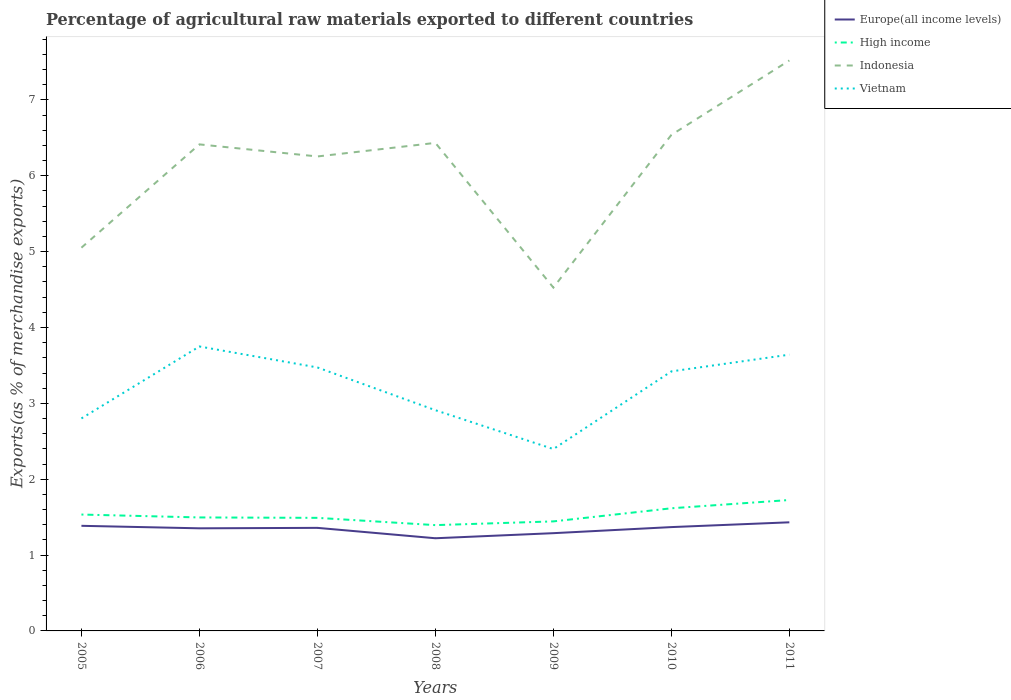How many different coloured lines are there?
Offer a terse response. 4. Does the line corresponding to High income intersect with the line corresponding to Indonesia?
Make the answer very short. No. Across all years, what is the maximum percentage of exports to different countries in Europe(all income levels)?
Your answer should be very brief. 1.22. In which year was the percentage of exports to different countries in Indonesia maximum?
Offer a terse response. 2009. What is the total percentage of exports to different countries in Indonesia in the graph?
Your answer should be very brief. 0.53. What is the difference between the highest and the second highest percentage of exports to different countries in Vietnam?
Your answer should be compact. 1.35. How many lines are there?
Provide a succinct answer. 4. How many years are there in the graph?
Provide a succinct answer. 7. What is the difference between two consecutive major ticks on the Y-axis?
Offer a terse response. 1. Are the values on the major ticks of Y-axis written in scientific E-notation?
Your answer should be compact. No. How are the legend labels stacked?
Provide a succinct answer. Vertical. What is the title of the graph?
Provide a short and direct response. Percentage of agricultural raw materials exported to different countries. Does "Germany" appear as one of the legend labels in the graph?
Offer a very short reply. No. What is the label or title of the Y-axis?
Your response must be concise. Exports(as % of merchandise exports). What is the Exports(as % of merchandise exports) in Europe(all income levels) in 2005?
Ensure brevity in your answer.  1.39. What is the Exports(as % of merchandise exports) of High income in 2005?
Your answer should be compact. 1.53. What is the Exports(as % of merchandise exports) of Indonesia in 2005?
Provide a succinct answer. 5.05. What is the Exports(as % of merchandise exports) in Vietnam in 2005?
Offer a very short reply. 2.8. What is the Exports(as % of merchandise exports) of Europe(all income levels) in 2006?
Your answer should be compact. 1.35. What is the Exports(as % of merchandise exports) of High income in 2006?
Give a very brief answer. 1.5. What is the Exports(as % of merchandise exports) in Indonesia in 2006?
Provide a succinct answer. 6.41. What is the Exports(as % of merchandise exports) in Vietnam in 2006?
Provide a succinct answer. 3.75. What is the Exports(as % of merchandise exports) in Europe(all income levels) in 2007?
Make the answer very short. 1.36. What is the Exports(as % of merchandise exports) in High income in 2007?
Offer a terse response. 1.49. What is the Exports(as % of merchandise exports) of Indonesia in 2007?
Ensure brevity in your answer.  6.25. What is the Exports(as % of merchandise exports) of Vietnam in 2007?
Your answer should be very brief. 3.47. What is the Exports(as % of merchandise exports) in Europe(all income levels) in 2008?
Offer a very short reply. 1.22. What is the Exports(as % of merchandise exports) in High income in 2008?
Offer a terse response. 1.39. What is the Exports(as % of merchandise exports) in Indonesia in 2008?
Your response must be concise. 6.43. What is the Exports(as % of merchandise exports) in Vietnam in 2008?
Offer a very short reply. 2.91. What is the Exports(as % of merchandise exports) in Europe(all income levels) in 2009?
Provide a short and direct response. 1.29. What is the Exports(as % of merchandise exports) of High income in 2009?
Ensure brevity in your answer.  1.44. What is the Exports(as % of merchandise exports) of Indonesia in 2009?
Provide a succinct answer. 4.53. What is the Exports(as % of merchandise exports) in Vietnam in 2009?
Provide a short and direct response. 2.4. What is the Exports(as % of merchandise exports) of Europe(all income levels) in 2010?
Make the answer very short. 1.37. What is the Exports(as % of merchandise exports) in High income in 2010?
Your answer should be very brief. 1.62. What is the Exports(as % of merchandise exports) in Indonesia in 2010?
Give a very brief answer. 6.54. What is the Exports(as % of merchandise exports) of Vietnam in 2010?
Give a very brief answer. 3.42. What is the Exports(as % of merchandise exports) in Europe(all income levels) in 2011?
Your answer should be very brief. 1.43. What is the Exports(as % of merchandise exports) of High income in 2011?
Offer a very short reply. 1.73. What is the Exports(as % of merchandise exports) of Indonesia in 2011?
Provide a short and direct response. 7.52. What is the Exports(as % of merchandise exports) of Vietnam in 2011?
Give a very brief answer. 3.64. Across all years, what is the maximum Exports(as % of merchandise exports) in Europe(all income levels)?
Offer a terse response. 1.43. Across all years, what is the maximum Exports(as % of merchandise exports) in High income?
Ensure brevity in your answer.  1.73. Across all years, what is the maximum Exports(as % of merchandise exports) of Indonesia?
Your answer should be very brief. 7.52. Across all years, what is the maximum Exports(as % of merchandise exports) in Vietnam?
Your response must be concise. 3.75. Across all years, what is the minimum Exports(as % of merchandise exports) of Europe(all income levels)?
Ensure brevity in your answer.  1.22. Across all years, what is the minimum Exports(as % of merchandise exports) in High income?
Make the answer very short. 1.39. Across all years, what is the minimum Exports(as % of merchandise exports) in Indonesia?
Make the answer very short. 4.53. Across all years, what is the minimum Exports(as % of merchandise exports) in Vietnam?
Your response must be concise. 2.4. What is the total Exports(as % of merchandise exports) in Europe(all income levels) in the graph?
Your response must be concise. 9.41. What is the total Exports(as % of merchandise exports) of High income in the graph?
Offer a very short reply. 10.7. What is the total Exports(as % of merchandise exports) of Indonesia in the graph?
Your answer should be very brief. 42.74. What is the total Exports(as % of merchandise exports) in Vietnam in the graph?
Your answer should be compact. 22.4. What is the difference between the Exports(as % of merchandise exports) in Europe(all income levels) in 2005 and that in 2006?
Provide a short and direct response. 0.03. What is the difference between the Exports(as % of merchandise exports) of High income in 2005 and that in 2006?
Offer a terse response. 0.04. What is the difference between the Exports(as % of merchandise exports) of Indonesia in 2005 and that in 2006?
Offer a terse response. -1.36. What is the difference between the Exports(as % of merchandise exports) of Vietnam in 2005 and that in 2006?
Keep it short and to the point. -0.95. What is the difference between the Exports(as % of merchandise exports) in Europe(all income levels) in 2005 and that in 2007?
Offer a terse response. 0.03. What is the difference between the Exports(as % of merchandise exports) in High income in 2005 and that in 2007?
Offer a very short reply. 0.04. What is the difference between the Exports(as % of merchandise exports) in Indonesia in 2005 and that in 2007?
Ensure brevity in your answer.  -1.2. What is the difference between the Exports(as % of merchandise exports) of Vietnam in 2005 and that in 2007?
Offer a very short reply. -0.67. What is the difference between the Exports(as % of merchandise exports) in Europe(all income levels) in 2005 and that in 2008?
Your answer should be compact. 0.16. What is the difference between the Exports(as % of merchandise exports) in High income in 2005 and that in 2008?
Keep it short and to the point. 0.14. What is the difference between the Exports(as % of merchandise exports) of Indonesia in 2005 and that in 2008?
Give a very brief answer. -1.38. What is the difference between the Exports(as % of merchandise exports) of Vietnam in 2005 and that in 2008?
Provide a short and direct response. -0.11. What is the difference between the Exports(as % of merchandise exports) of Europe(all income levels) in 2005 and that in 2009?
Your response must be concise. 0.1. What is the difference between the Exports(as % of merchandise exports) in High income in 2005 and that in 2009?
Ensure brevity in your answer.  0.09. What is the difference between the Exports(as % of merchandise exports) of Indonesia in 2005 and that in 2009?
Make the answer very short. 0.53. What is the difference between the Exports(as % of merchandise exports) of Vietnam in 2005 and that in 2009?
Your response must be concise. 0.4. What is the difference between the Exports(as % of merchandise exports) of Europe(all income levels) in 2005 and that in 2010?
Ensure brevity in your answer.  0.02. What is the difference between the Exports(as % of merchandise exports) of High income in 2005 and that in 2010?
Offer a very short reply. -0.08. What is the difference between the Exports(as % of merchandise exports) in Indonesia in 2005 and that in 2010?
Keep it short and to the point. -1.49. What is the difference between the Exports(as % of merchandise exports) of Vietnam in 2005 and that in 2010?
Ensure brevity in your answer.  -0.62. What is the difference between the Exports(as % of merchandise exports) of Europe(all income levels) in 2005 and that in 2011?
Ensure brevity in your answer.  -0.05. What is the difference between the Exports(as % of merchandise exports) in High income in 2005 and that in 2011?
Offer a terse response. -0.19. What is the difference between the Exports(as % of merchandise exports) in Indonesia in 2005 and that in 2011?
Ensure brevity in your answer.  -2.47. What is the difference between the Exports(as % of merchandise exports) in Vietnam in 2005 and that in 2011?
Give a very brief answer. -0.84. What is the difference between the Exports(as % of merchandise exports) of Europe(all income levels) in 2006 and that in 2007?
Offer a terse response. -0.01. What is the difference between the Exports(as % of merchandise exports) of High income in 2006 and that in 2007?
Ensure brevity in your answer.  0.01. What is the difference between the Exports(as % of merchandise exports) of Indonesia in 2006 and that in 2007?
Keep it short and to the point. 0.16. What is the difference between the Exports(as % of merchandise exports) of Vietnam in 2006 and that in 2007?
Your answer should be very brief. 0.28. What is the difference between the Exports(as % of merchandise exports) in Europe(all income levels) in 2006 and that in 2008?
Your answer should be compact. 0.13. What is the difference between the Exports(as % of merchandise exports) of High income in 2006 and that in 2008?
Your response must be concise. 0.1. What is the difference between the Exports(as % of merchandise exports) of Indonesia in 2006 and that in 2008?
Make the answer very short. -0.02. What is the difference between the Exports(as % of merchandise exports) in Vietnam in 2006 and that in 2008?
Offer a terse response. 0.84. What is the difference between the Exports(as % of merchandise exports) of Europe(all income levels) in 2006 and that in 2009?
Your answer should be compact. 0.06. What is the difference between the Exports(as % of merchandise exports) of High income in 2006 and that in 2009?
Your response must be concise. 0.05. What is the difference between the Exports(as % of merchandise exports) of Indonesia in 2006 and that in 2009?
Your answer should be compact. 1.89. What is the difference between the Exports(as % of merchandise exports) of Vietnam in 2006 and that in 2009?
Offer a very short reply. 1.35. What is the difference between the Exports(as % of merchandise exports) in Europe(all income levels) in 2006 and that in 2010?
Provide a short and direct response. -0.02. What is the difference between the Exports(as % of merchandise exports) of High income in 2006 and that in 2010?
Offer a very short reply. -0.12. What is the difference between the Exports(as % of merchandise exports) of Indonesia in 2006 and that in 2010?
Offer a terse response. -0.13. What is the difference between the Exports(as % of merchandise exports) of Vietnam in 2006 and that in 2010?
Provide a short and direct response. 0.33. What is the difference between the Exports(as % of merchandise exports) of Europe(all income levels) in 2006 and that in 2011?
Provide a short and direct response. -0.08. What is the difference between the Exports(as % of merchandise exports) of High income in 2006 and that in 2011?
Your response must be concise. -0.23. What is the difference between the Exports(as % of merchandise exports) of Indonesia in 2006 and that in 2011?
Your response must be concise. -1.11. What is the difference between the Exports(as % of merchandise exports) of Vietnam in 2006 and that in 2011?
Ensure brevity in your answer.  0.11. What is the difference between the Exports(as % of merchandise exports) of Europe(all income levels) in 2007 and that in 2008?
Provide a succinct answer. 0.14. What is the difference between the Exports(as % of merchandise exports) of High income in 2007 and that in 2008?
Your answer should be compact. 0.1. What is the difference between the Exports(as % of merchandise exports) of Indonesia in 2007 and that in 2008?
Offer a very short reply. -0.18. What is the difference between the Exports(as % of merchandise exports) of Vietnam in 2007 and that in 2008?
Your answer should be very brief. 0.56. What is the difference between the Exports(as % of merchandise exports) of Europe(all income levels) in 2007 and that in 2009?
Give a very brief answer. 0.07. What is the difference between the Exports(as % of merchandise exports) in High income in 2007 and that in 2009?
Provide a succinct answer. 0.05. What is the difference between the Exports(as % of merchandise exports) in Indonesia in 2007 and that in 2009?
Offer a terse response. 1.73. What is the difference between the Exports(as % of merchandise exports) in Vietnam in 2007 and that in 2009?
Offer a very short reply. 1.08. What is the difference between the Exports(as % of merchandise exports) of Europe(all income levels) in 2007 and that in 2010?
Your response must be concise. -0.01. What is the difference between the Exports(as % of merchandise exports) of High income in 2007 and that in 2010?
Ensure brevity in your answer.  -0.13. What is the difference between the Exports(as % of merchandise exports) in Indonesia in 2007 and that in 2010?
Offer a very short reply. -0.28. What is the difference between the Exports(as % of merchandise exports) of Vietnam in 2007 and that in 2010?
Offer a very short reply. 0.05. What is the difference between the Exports(as % of merchandise exports) of Europe(all income levels) in 2007 and that in 2011?
Ensure brevity in your answer.  -0.07. What is the difference between the Exports(as % of merchandise exports) in High income in 2007 and that in 2011?
Give a very brief answer. -0.24. What is the difference between the Exports(as % of merchandise exports) of Indonesia in 2007 and that in 2011?
Your response must be concise. -1.27. What is the difference between the Exports(as % of merchandise exports) in Vietnam in 2007 and that in 2011?
Give a very brief answer. -0.17. What is the difference between the Exports(as % of merchandise exports) of Europe(all income levels) in 2008 and that in 2009?
Ensure brevity in your answer.  -0.07. What is the difference between the Exports(as % of merchandise exports) of High income in 2008 and that in 2009?
Keep it short and to the point. -0.05. What is the difference between the Exports(as % of merchandise exports) in Indonesia in 2008 and that in 2009?
Give a very brief answer. 1.91. What is the difference between the Exports(as % of merchandise exports) in Vietnam in 2008 and that in 2009?
Offer a very short reply. 0.51. What is the difference between the Exports(as % of merchandise exports) of Europe(all income levels) in 2008 and that in 2010?
Give a very brief answer. -0.15. What is the difference between the Exports(as % of merchandise exports) in High income in 2008 and that in 2010?
Give a very brief answer. -0.22. What is the difference between the Exports(as % of merchandise exports) in Indonesia in 2008 and that in 2010?
Provide a short and direct response. -0.11. What is the difference between the Exports(as % of merchandise exports) in Vietnam in 2008 and that in 2010?
Your response must be concise. -0.51. What is the difference between the Exports(as % of merchandise exports) in Europe(all income levels) in 2008 and that in 2011?
Your response must be concise. -0.21. What is the difference between the Exports(as % of merchandise exports) in High income in 2008 and that in 2011?
Give a very brief answer. -0.33. What is the difference between the Exports(as % of merchandise exports) of Indonesia in 2008 and that in 2011?
Provide a succinct answer. -1.09. What is the difference between the Exports(as % of merchandise exports) of Vietnam in 2008 and that in 2011?
Offer a terse response. -0.73. What is the difference between the Exports(as % of merchandise exports) in Europe(all income levels) in 2009 and that in 2010?
Ensure brevity in your answer.  -0.08. What is the difference between the Exports(as % of merchandise exports) in High income in 2009 and that in 2010?
Keep it short and to the point. -0.17. What is the difference between the Exports(as % of merchandise exports) of Indonesia in 2009 and that in 2010?
Offer a very short reply. -2.01. What is the difference between the Exports(as % of merchandise exports) of Vietnam in 2009 and that in 2010?
Your response must be concise. -1.02. What is the difference between the Exports(as % of merchandise exports) in Europe(all income levels) in 2009 and that in 2011?
Ensure brevity in your answer.  -0.14. What is the difference between the Exports(as % of merchandise exports) in High income in 2009 and that in 2011?
Your answer should be very brief. -0.28. What is the difference between the Exports(as % of merchandise exports) in Indonesia in 2009 and that in 2011?
Your answer should be very brief. -2.99. What is the difference between the Exports(as % of merchandise exports) in Vietnam in 2009 and that in 2011?
Your answer should be compact. -1.24. What is the difference between the Exports(as % of merchandise exports) in Europe(all income levels) in 2010 and that in 2011?
Keep it short and to the point. -0.06. What is the difference between the Exports(as % of merchandise exports) of High income in 2010 and that in 2011?
Your answer should be very brief. -0.11. What is the difference between the Exports(as % of merchandise exports) of Indonesia in 2010 and that in 2011?
Provide a succinct answer. -0.98. What is the difference between the Exports(as % of merchandise exports) in Vietnam in 2010 and that in 2011?
Keep it short and to the point. -0.22. What is the difference between the Exports(as % of merchandise exports) of Europe(all income levels) in 2005 and the Exports(as % of merchandise exports) of High income in 2006?
Your answer should be very brief. -0.11. What is the difference between the Exports(as % of merchandise exports) in Europe(all income levels) in 2005 and the Exports(as % of merchandise exports) in Indonesia in 2006?
Give a very brief answer. -5.03. What is the difference between the Exports(as % of merchandise exports) of Europe(all income levels) in 2005 and the Exports(as % of merchandise exports) of Vietnam in 2006?
Your answer should be very brief. -2.36. What is the difference between the Exports(as % of merchandise exports) in High income in 2005 and the Exports(as % of merchandise exports) in Indonesia in 2006?
Your answer should be compact. -4.88. What is the difference between the Exports(as % of merchandise exports) of High income in 2005 and the Exports(as % of merchandise exports) of Vietnam in 2006?
Your response must be concise. -2.22. What is the difference between the Exports(as % of merchandise exports) in Indonesia in 2005 and the Exports(as % of merchandise exports) in Vietnam in 2006?
Ensure brevity in your answer.  1.3. What is the difference between the Exports(as % of merchandise exports) of Europe(all income levels) in 2005 and the Exports(as % of merchandise exports) of High income in 2007?
Offer a terse response. -0.1. What is the difference between the Exports(as % of merchandise exports) of Europe(all income levels) in 2005 and the Exports(as % of merchandise exports) of Indonesia in 2007?
Ensure brevity in your answer.  -4.87. What is the difference between the Exports(as % of merchandise exports) of Europe(all income levels) in 2005 and the Exports(as % of merchandise exports) of Vietnam in 2007?
Provide a succinct answer. -2.09. What is the difference between the Exports(as % of merchandise exports) in High income in 2005 and the Exports(as % of merchandise exports) in Indonesia in 2007?
Provide a short and direct response. -4.72. What is the difference between the Exports(as % of merchandise exports) in High income in 2005 and the Exports(as % of merchandise exports) in Vietnam in 2007?
Make the answer very short. -1.94. What is the difference between the Exports(as % of merchandise exports) in Indonesia in 2005 and the Exports(as % of merchandise exports) in Vietnam in 2007?
Keep it short and to the point. 1.58. What is the difference between the Exports(as % of merchandise exports) in Europe(all income levels) in 2005 and the Exports(as % of merchandise exports) in High income in 2008?
Your answer should be very brief. -0.01. What is the difference between the Exports(as % of merchandise exports) in Europe(all income levels) in 2005 and the Exports(as % of merchandise exports) in Indonesia in 2008?
Give a very brief answer. -5.05. What is the difference between the Exports(as % of merchandise exports) of Europe(all income levels) in 2005 and the Exports(as % of merchandise exports) of Vietnam in 2008?
Provide a succinct answer. -1.52. What is the difference between the Exports(as % of merchandise exports) in High income in 2005 and the Exports(as % of merchandise exports) in Indonesia in 2008?
Offer a very short reply. -4.9. What is the difference between the Exports(as % of merchandise exports) in High income in 2005 and the Exports(as % of merchandise exports) in Vietnam in 2008?
Provide a succinct answer. -1.38. What is the difference between the Exports(as % of merchandise exports) in Indonesia in 2005 and the Exports(as % of merchandise exports) in Vietnam in 2008?
Offer a terse response. 2.14. What is the difference between the Exports(as % of merchandise exports) of Europe(all income levels) in 2005 and the Exports(as % of merchandise exports) of High income in 2009?
Provide a succinct answer. -0.06. What is the difference between the Exports(as % of merchandise exports) in Europe(all income levels) in 2005 and the Exports(as % of merchandise exports) in Indonesia in 2009?
Your response must be concise. -3.14. What is the difference between the Exports(as % of merchandise exports) in Europe(all income levels) in 2005 and the Exports(as % of merchandise exports) in Vietnam in 2009?
Your answer should be very brief. -1.01. What is the difference between the Exports(as % of merchandise exports) in High income in 2005 and the Exports(as % of merchandise exports) in Indonesia in 2009?
Provide a succinct answer. -2.99. What is the difference between the Exports(as % of merchandise exports) in High income in 2005 and the Exports(as % of merchandise exports) in Vietnam in 2009?
Provide a short and direct response. -0.86. What is the difference between the Exports(as % of merchandise exports) of Indonesia in 2005 and the Exports(as % of merchandise exports) of Vietnam in 2009?
Your response must be concise. 2.65. What is the difference between the Exports(as % of merchandise exports) in Europe(all income levels) in 2005 and the Exports(as % of merchandise exports) in High income in 2010?
Give a very brief answer. -0.23. What is the difference between the Exports(as % of merchandise exports) of Europe(all income levels) in 2005 and the Exports(as % of merchandise exports) of Indonesia in 2010?
Your answer should be compact. -5.15. What is the difference between the Exports(as % of merchandise exports) in Europe(all income levels) in 2005 and the Exports(as % of merchandise exports) in Vietnam in 2010?
Provide a succinct answer. -2.04. What is the difference between the Exports(as % of merchandise exports) of High income in 2005 and the Exports(as % of merchandise exports) of Indonesia in 2010?
Your answer should be very brief. -5. What is the difference between the Exports(as % of merchandise exports) in High income in 2005 and the Exports(as % of merchandise exports) in Vietnam in 2010?
Keep it short and to the point. -1.89. What is the difference between the Exports(as % of merchandise exports) in Indonesia in 2005 and the Exports(as % of merchandise exports) in Vietnam in 2010?
Offer a very short reply. 1.63. What is the difference between the Exports(as % of merchandise exports) of Europe(all income levels) in 2005 and the Exports(as % of merchandise exports) of High income in 2011?
Offer a very short reply. -0.34. What is the difference between the Exports(as % of merchandise exports) of Europe(all income levels) in 2005 and the Exports(as % of merchandise exports) of Indonesia in 2011?
Provide a succinct answer. -6.13. What is the difference between the Exports(as % of merchandise exports) in Europe(all income levels) in 2005 and the Exports(as % of merchandise exports) in Vietnam in 2011?
Offer a very short reply. -2.26. What is the difference between the Exports(as % of merchandise exports) in High income in 2005 and the Exports(as % of merchandise exports) in Indonesia in 2011?
Provide a succinct answer. -5.99. What is the difference between the Exports(as % of merchandise exports) of High income in 2005 and the Exports(as % of merchandise exports) of Vietnam in 2011?
Your response must be concise. -2.11. What is the difference between the Exports(as % of merchandise exports) in Indonesia in 2005 and the Exports(as % of merchandise exports) in Vietnam in 2011?
Your answer should be compact. 1.41. What is the difference between the Exports(as % of merchandise exports) of Europe(all income levels) in 2006 and the Exports(as % of merchandise exports) of High income in 2007?
Your response must be concise. -0.14. What is the difference between the Exports(as % of merchandise exports) of Europe(all income levels) in 2006 and the Exports(as % of merchandise exports) of Indonesia in 2007?
Provide a succinct answer. -4.9. What is the difference between the Exports(as % of merchandise exports) in Europe(all income levels) in 2006 and the Exports(as % of merchandise exports) in Vietnam in 2007?
Make the answer very short. -2.12. What is the difference between the Exports(as % of merchandise exports) in High income in 2006 and the Exports(as % of merchandise exports) in Indonesia in 2007?
Offer a terse response. -4.76. What is the difference between the Exports(as % of merchandise exports) in High income in 2006 and the Exports(as % of merchandise exports) in Vietnam in 2007?
Provide a short and direct response. -1.98. What is the difference between the Exports(as % of merchandise exports) of Indonesia in 2006 and the Exports(as % of merchandise exports) of Vietnam in 2007?
Keep it short and to the point. 2.94. What is the difference between the Exports(as % of merchandise exports) of Europe(all income levels) in 2006 and the Exports(as % of merchandise exports) of High income in 2008?
Make the answer very short. -0.04. What is the difference between the Exports(as % of merchandise exports) in Europe(all income levels) in 2006 and the Exports(as % of merchandise exports) in Indonesia in 2008?
Give a very brief answer. -5.08. What is the difference between the Exports(as % of merchandise exports) in Europe(all income levels) in 2006 and the Exports(as % of merchandise exports) in Vietnam in 2008?
Offer a terse response. -1.56. What is the difference between the Exports(as % of merchandise exports) of High income in 2006 and the Exports(as % of merchandise exports) of Indonesia in 2008?
Offer a very short reply. -4.94. What is the difference between the Exports(as % of merchandise exports) in High income in 2006 and the Exports(as % of merchandise exports) in Vietnam in 2008?
Your answer should be compact. -1.41. What is the difference between the Exports(as % of merchandise exports) in Indonesia in 2006 and the Exports(as % of merchandise exports) in Vietnam in 2008?
Your answer should be very brief. 3.5. What is the difference between the Exports(as % of merchandise exports) in Europe(all income levels) in 2006 and the Exports(as % of merchandise exports) in High income in 2009?
Keep it short and to the point. -0.09. What is the difference between the Exports(as % of merchandise exports) of Europe(all income levels) in 2006 and the Exports(as % of merchandise exports) of Indonesia in 2009?
Make the answer very short. -3.17. What is the difference between the Exports(as % of merchandise exports) of Europe(all income levels) in 2006 and the Exports(as % of merchandise exports) of Vietnam in 2009?
Your answer should be compact. -1.04. What is the difference between the Exports(as % of merchandise exports) in High income in 2006 and the Exports(as % of merchandise exports) in Indonesia in 2009?
Make the answer very short. -3.03. What is the difference between the Exports(as % of merchandise exports) of High income in 2006 and the Exports(as % of merchandise exports) of Vietnam in 2009?
Offer a very short reply. -0.9. What is the difference between the Exports(as % of merchandise exports) of Indonesia in 2006 and the Exports(as % of merchandise exports) of Vietnam in 2009?
Provide a succinct answer. 4.02. What is the difference between the Exports(as % of merchandise exports) of Europe(all income levels) in 2006 and the Exports(as % of merchandise exports) of High income in 2010?
Your answer should be compact. -0.26. What is the difference between the Exports(as % of merchandise exports) of Europe(all income levels) in 2006 and the Exports(as % of merchandise exports) of Indonesia in 2010?
Offer a terse response. -5.19. What is the difference between the Exports(as % of merchandise exports) in Europe(all income levels) in 2006 and the Exports(as % of merchandise exports) in Vietnam in 2010?
Make the answer very short. -2.07. What is the difference between the Exports(as % of merchandise exports) of High income in 2006 and the Exports(as % of merchandise exports) of Indonesia in 2010?
Keep it short and to the point. -5.04. What is the difference between the Exports(as % of merchandise exports) of High income in 2006 and the Exports(as % of merchandise exports) of Vietnam in 2010?
Keep it short and to the point. -1.93. What is the difference between the Exports(as % of merchandise exports) of Indonesia in 2006 and the Exports(as % of merchandise exports) of Vietnam in 2010?
Your response must be concise. 2.99. What is the difference between the Exports(as % of merchandise exports) of Europe(all income levels) in 2006 and the Exports(as % of merchandise exports) of High income in 2011?
Your response must be concise. -0.37. What is the difference between the Exports(as % of merchandise exports) of Europe(all income levels) in 2006 and the Exports(as % of merchandise exports) of Indonesia in 2011?
Offer a terse response. -6.17. What is the difference between the Exports(as % of merchandise exports) in Europe(all income levels) in 2006 and the Exports(as % of merchandise exports) in Vietnam in 2011?
Offer a terse response. -2.29. What is the difference between the Exports(as % of merchandise exports) in High income in 2006 and the Exports(as % of merchandise exports) in Indonesia in 2011?
Offer a very short reply. -6.02. What is the difference between the Exports(as % of merchandise exports) of High income in 2006 and the Exports(as % of merchandise exports) of Vietnam in 2011?
Make the answer very short. -2.15. What is the difference between the Exports(as % of merchandise exports) of Indonesia in 2006 and the Exports(as % of merchandise exports) of Vietnam in 2011?
Your answer should be compact. 2.77. What is the difference between the Exports(as % of merchandise exports) of Europe(all income levels) in 2007 and the Exports(as % of merchandise exports) of High income in 2008?
Your answer should be compact. -0.04. What is the difference between the Exports(as % of merchandise exports) of Europe(all income levels) in 2007 and the Exports(as % of merchandise exports) of Indonesia in 2008?
Give a very brief answer. -5.08. What is the difference between the Exports(as % of merchandise exports) in Europe(all income levels) in 2007 and the Exports(as % of merchandise exports) in Vietnam in 2008?
Provide a short and direct response. -1.55. What is the difference between the Exports(as % of merchandise exports) in High income in 2007 and the Exports(as % of merchandise exports) in Indonesia in 2008?
Provide a short and direct response. -4.94. What is the difference between the Exports(as % of merchandise exports) in High income in 2007 and the Exports(as % of merchandise exports) in Vietnam in 2008?
Give a very brief answer. -1.42. What is the difference between the Exports(as % of merchandise exports) of Indonesia in 2007 and the Exports(as % of merchandise exports) of Vietnam in 2008?
Ensure brevity in your answer.  3.35. What is the difference between the Exports(as % of merchandise exports) of Europe(all income levels) in 2007 and the Exports(as % of merchandise exports) of High income in 2009?
Give a very brief answer. -0.09. What is the difference between the Exports(as % of merchandise exports) of Europe(all income levels) in 2007 and the Exports(as % of merchandise exports) of Indonesia in 2009?
Provide a succinct answer. -3.17. What is the difference between the Exports(as % of merchandise exports) of Europe(all income levels) in 2007 and the Exports(as % of merchandise exports) of Vietnam in 2009?
Your response must be concise. -1.04. What is the difference between the Exports(as % of merchandise exports) of High income in 2007 and the Exports(as % of merchandise exports) of Indonesia in 2009?
Keep it short and to the point. -3.04. What is the difference between the Exports(as % of merchandise exports) of High income in 2007 and the Exports(as % of merchandise exports) of Vietnam in 2009?
Your answer should be compact. -0.91. What is the difference between the Exports(as % of merchandise exports) of Indonesia in 2007 and the Exports(as % of merchandise exports) of Vietnam in 2009?
Give a very brief answer. 3.86. What is the difference between the Exports(as % of merchandise exports) in Europe(all income levels) in 2007 and the Exports(as % of merchandise exports) in High income in 2010?
Your response must be concise. -0.26. What is the difference between the Exports(as % of merchandise exports) of Europe(all income levels) in 2007 and the Exports(as % of merchandise exports) of Indonesia in 2010?
Your response must be concise. -5.18. What is the difference between the Exports(as % of merchandise exports) of Europe(all income levels) in 2007 and the Exports(as % of merchandise exports) of Vietnam in 2010?
Give a very brief answer. -2.06. What is the difference between the Exports(as % of merchandise exports) of High income in 2007 and the Exports(as % of merchandise exports) of Indonesia in 2010?
Your response must be concise. -5.05. What is the difference between the Exports(as % of merchandise exports) in High income in 2007 and the Exports(as % of merchandise exports) in Vietnam in 2010?
Give a very brief answer. -1.93. What is the difference between the Exports(as % of merchandise exports) in Indonesia in 2007 and the Exports(as % of merchandise exports) in Vietnam in 2010?
Offer a terse response. 2.83. What is the difference between the Exports(as % of merchandise exports) of Europe(all income levels) in 2007 and the Exports(as % of merchandise exports) of High income in 2011?
Keep it short and to the point. -0.37. What is the difference between the Exports(as % of merchandise exports) in Europe(all income levels) in 2007 and the Exports(as % of merchandise exports) in Indonesia in 2011?
Provide a short and direct response. -6.16. What is the difference between the Exports(as % of merchandise exports) in Europe(all income levels) in 2007 and the Exports(as % of merchandise exports) in Vietnam in 2011?
Ensure brevity in your answer.  -2.28. What is the difference between the Exports(as % of merchandise exports) of High income in 2007 and the Exports(as % of merchandise exports) of Indonesia in 2011?
Provide a succinct answer. -6.03. What is the difference between the Exports(as % of merchandise exports) of High income in 2007 and the Exports(as % of merchandise exports) of Vietnam in 2011?
Ensure brevity in your answer.  -2.15. What is the difference between the Exports(as % of merchandise exports) of Indonesia in 2007 and the Exports(as % of merchandise exports) of Vietnam in 2011?
Offer a very short reply. 2.61. What is the difference between the Exports(as % of merchandise exports) in Europe(all income levels) in 2008 and the Exports(as % of merchandise exports) in High income in 2009?
Keep it short and to the point. -0.22. What is the difference between the Exports(as % of merchandise exports) of Europe(all income levels) in 2008 and the Exports(as % of merchandise exports) of Indonesia in 2009?
Provide a short and direct response. -3.3. What is the difference between the Exports(as % of merchandise exports) of Europe(all income levels) in 2008 and the Exports(as % of merchandise exports) of Vietnam in 2009?
Your answer should be compact. -1.18. What is the difference between the Exports(as % of merchandise exports) in High income in 2008 and the Exports(as % of merchandise exports) in Indonesia in 2009?
Provide a succinct answer. -3.13. What is the difference between the Exports(as % of merchandise exports) of High income in 2008 and the Exports(as % of merchandise exports) of Vietnam in 2009?
Give a very brief answer. -1. What is the difference between the Exports(as % of merchandise exports) of Indonesia in 2008 and the Exports(as % of merchandise exports) of Vietnam in 2009?
Your response must be concise. 4.04. What is the difference between the Exports(as % of merchandise exports) of Europe(all income levels) in 2008 and the Exports(as % of merchandise exports) of High income in 2010?
Offer a very short reply. -0.4. What is the difference between the Exports(as % of merchandise exports) of Europe(all income levels) in 2008 and the Exports(as % of merchandise exports) of Indonesia in 2010?
Ensure brevity in your answer.  -5.32. What is the difference between the Exports(as % of merchandise exports) of Europe(all income levels) in 2008 and the Exports(as % of merchandise exports) of Vietnam in 2010?
Ensure brevity in your answer.  -2.2. What is the difference between the Exports(as % of merchandise exports) in High income in 2008 and the Exports(as % of merchandise exports) in Indonesia in 2010?
Ensure brevity in your answer.  -5.14. What is the difference between the Exports(as % of merchandise exports) of High income in 2008 and the Exports(as % of merchandise exports) of Vietnam in 2010?
Your answer should be compact. -2.03. What is the difference between the Exports(as % of merchandise exports) of Indonesia in 2008 and the Exports(as % of merchandise exports) of Vietnam in 2010?
Your response must be concise. 3.01. What is the difference between the Exports(as % of merchandise exports) in Europe(all income levels) in 2008 and the Exports(as % of merchandise exports) in High income in 2011?
Give a very brief answer. -0.5. What is the difference between the Exports(as % of merchandise exports) of Europe(all income levels) in 2008 and the Exports(as % of merchandise exports) of Indonesia in 2011?
Give a very brief answer. -6.3. What is the difference between the Exports(as % of merchandise exports) in Europe(all income levels) in 2008 and the Exports(as % of merchandise exports) in Vietnam in 2011?
Make the answer very short. -2.42. What is the difference between the Exports(as % of merchandise exports) in High income in 2008 and the Exports(as % of merchandise exports) in Indonesia in 2011?
Give a very brief answer. -6.13. What is the difference between the Exports(as % of merchandise exports) in High income in 2008 and the Exports(as % of merchandise exports) in Vietnam in 2011?
Provide a short and direct response. -2.25. What is the difference between the Exports(as % of merchandise exports) in Indonesia in 2008 and the Exports(as % of merchandise exports) in Vietnam in 2011?
Offer a very short reply. 2.79. What is the difference between the Exports(as % of merchandise exports) in Europe(all income levels) in 2009 and the Exports(as % of merchandise exports) in High income in 2010?
Make the answer very short. -0.33. What is the difference between the Exports(as % of merchandise exports) of Europe(all income levels) in 2009 and the Exports(as % of merchandise exports) of Indonesia in 2010?
Offer a very short reply. -5.25. What is the difference between the Exports(as % of merchandise exports) of Europe(all income levels) in 2009 and the Exports(as % of merchandise exports) of Vietnam in 2010?
Your response must be concise. -2.13. What is the difference between the Exports(as % of merchandise exports) of High income in 2009 and the Exports(as % of merchandise exports) of Indonesia in 2010?
Provide a succinct answer. -5.1. What is the difference between the Exports(as % of merchandise exports) in High income in 2009 and the Exports(as % of merchandise exports) in Vietnam in 2010?
Provide a succinct answer. -1.98. What is the difference between the Exports(as % of merchandise exports) of Indonesia in 2009 and the Exports(as % of merchandise exports) of Vietnam in 2010?
Keep it short and to the point. 1.1. What is the difference between the Exports(as % of merchandise exports) of Europe(all income levels) in 2009 and the Exports(as % of merchandise exports) of High income in 2011?
Your answer should be very brief. -0.44. What is the difference between the Exports(as % of merchandise exports) of Europe(all income levels) in 2009 and the Exports(as % of merchandise exports) of Indonesia in 2011?
Provide a succinct answer. -6.23. What is the difference between the Exports(as % of merchandise exports) in Europe(all income levels) in 2009 and the Exports(as % of merchandise exports) in Vietnam in 2011?
Your answer should be very brief. -2.35. What is the difference between the Exports(as % of merchandise exports) of High income in 2009 and the Exports(as % of merchandise exports) of Indonesia in 2011?
Ensure brevity in your answer.  -6.08. What is the difference between the Exports(as % of merchandise exports) of High income in 2009 and the Exports(as % of merchandise exports) of Vietnam in 2011?
Keep it short and to the point. -2.2. What is the difference between the Exports(as % of merchandise exports) of Indonesia in 2009 and the Exports(as % of merchandise exports) of Vietnam in 2011?
Your answer should be compact. 0.88. What is the difference between the Exports(as % of merchandise exports) of Europe(all income levels) in 2010 and the Exports(as % of merchandise exports) of High income in 2011?
Provide a succinct answer. -0.36. What is the difference between the Exports(as % of merchandise exports) in Europe(all income levels) in 2010 and the Exports(as % of merchandise exports) in Indonesia in 2011?
Offer a very short reply. -6.15. What is the difference between the Exports(as % of merchandise exports) of Europe(all income levels) in 2010 and the Exports(as % of merchandise exports) of Vietnam in 2011?
Give a very brief answer. -2.27. What is the difference between the Exports(as % of merchandise exports) in High income in 2010 and the Exports(as % of merchandise exports) in Indonesia in 2011?
Make the answer very short. -5.9. What is the difference between the Exports(as % of merchandise exports) in High income in 2010 and the Exports(as % of merchandise exports) in Vietnam in 2011?
Make the answer very short. -2.03. What is the difference between the Exports(as % of merchandise exports) in Indonesia in 2010 and the Exports(as % of merchandise exports) in Vietnam in 2011?
Offer a terse response. 2.9. What is the average Exports(as % of merchandise exports) in Europe(all income levels) per year?
Offer a terse response. 1.34. What is the average Exports(as % of merchandise exports) in High income per year?
Give a very brief answer. 1.53. What is the average Exports(as % of merchandise exports) in Indonesia per year?
Give a very brief answer. 6.11. What is the average Exports(as % of merchandise exports) in Vietnam per year?
Give a very brief answer. 3.2. In the year 2005, what is the difference between the Exports(as % of merchandise exports) of Europe(all income levels) and Exports(as % of merchandise exports) of High income?
Ensure brevity in your answer.  -0.15. In the year 2005, what is the difference between the Exports(as % of merchandise exports) of Europe(all income levels) and Exports(as % of merchandise exports) of Indonesia?
Keep it short and to the point. -3.67. In the year 2005, what is the difference between the Exports(as % of merchandise exports) of Europe(all income levels) and Exports(as % of merchandise exports) of Vietnam?
Provide a succinct answer. -1.42. In the year 2005, what is the difference between the Exports(as % of merchandise exports) in High income and Exports(as % of merchandise exports) in Indonesia?
Give a very brief answer. -3.52. In the year 2005, what is the difference between the Exports(as % of merchandise exports) of High income and Exports(as % of merchandise exports) of Vietnam?
Ensure brevity in your answer.  -1.27. In the year 2005, what is the difference between the Exports(as % of merchandise exports) of Indonesia and Exports(as % of merchandise exports) of Vietnam?
Give a very brief answer. 2.25. In the year 2006, what is the difference between the Exports(as % of merchandise exports) of Europe(all income levels) and Exports(as % of merchandise exports) of High income?
Make the answer very short. -0.14. In the year 2006, what is the difference between the Exports(as % of merchandise exports) of Europe(all income levels) and Exports(as % of merchandise exports) of Indonesia?
Your response must be concise. -5.06. In the year 2006, what is the difference between the Exports(as % of merchandise exports) in Europe(all income levels) and Exports(as % of merchandise exports) in Vietnam?
Your answer should be very brief. -2.4. In the year 2006, what is the difference between the Exports(as % of merchandise exports) in High income and Exports(as % of merchandise exports) in Indonesia?
Keep it short and to the point. -4.92. In the year 2006, what is the difference between the Exports(as % of merchandise exports) of High income and Exports(as % of merchandise exports) of Vietnam?
Offer a terse response. -2.25. In the year 2006, what is the difference between the Exports(as % of merchandise exports) of Indonesia and Exports(as % of merchandise exports) of Vietnam?
Give a very brief answer. 2.66. In the year 2007, what is the difference between the Exports(as % of merchandise exports) in Europe(all income levels) and Exports(as % of merchandise exports) in High income?
Provide a short and direct response. -0.13. In the year 2007, what is the difference between the Exports(as % of merchandise exports) in Europe(all income levels) and Exports(as % of merchandise exports) in Indonesia?
Ensure brevity in your answer.  -4.9. In the year 2007, what is the difference between the Exports(as % of merchandise exports) of Europe(all income levels) and Exports(as % of merchandise exports) of Vietnam?
Your answer should be very brief. -2.11. In the year 2007, what is the difference between the Exports(as % of merchandise exports) in High income and Exports(as % of merchandise exports) in Indonesia?
Your response must be concise. -4.76. In the year 2007, what is the difference between the Exports(as % of merchandise exports) of High income and Exports(as % of merchandise exports) of Vietnam?
Give a very brief answer. -1.98. In the year 2007, what is the difference between the Exports(as % of merchandise exports) of Indonesia and Exports(as % of merchandise exports) of Vietnam?
Keep it short and to the point. 2.78. In the year 2008, what is the difference between the Exports(as % of merchandise exports) in Europe(all income levels) and Exports(as % of merchandise exports) in High income?
Your answer should be very brief. -0.17. In the year 2008, what is the difference between the Exports(as % of merchandise exports) of Europe(all income levels) and Exports(as % of merchandise exports) of Indonesia?
Provide a succinct answer. -5.21. In the year 2008, what is the difference between the Exports(as % of merchandise exports) of Europe(all income levels) and Exports(as % of merchandise exports) of Vietnam?
Your answer should be very brief. -1.69. In the year 2008, what is the difference between the Exports(as % of merchandise exports) of High income and Exports(as % of merchandise exports) of Indonesia?
Your response must be concise. -5.04. In the year 2008, what is the difference between the Exports(as % of merchandise exports) in High income and Exports(as % of merchandise exports) in Vietnam?
Your response must be concise. -1.52. In the year 2008, what is the difference between the Exports(as % of merchandise exports) of Indonesia and Exports(as % of merchandise exports) of Vietnam?
Your answer should be compact. 3.52. In the year 2009, what is the difference between the Exports(as % of merchandise exports) in Europe(all income levels) and Exports(as % of merchandise exports) in High income?
Give a very brief answer. -0.16. In the year 2009, what is the difference between the Exports(as % of merchandise exports) in Europe(all income levels) and Exports(as % of merchandise exports) in Indonesia?
Your answer should be very brief. -3.24. In the year 2009, what is the difference between the Exports(as % of merchandise exports) in Europe(all income levels) and Exports(as % of merchandise exports) in Vietnam?
Ensure brevity in your answer.  -1.11. In the year 2009, what is the difference between the Exports(as % of merchandise exports) of High income and Exports(as % of merchandise exports) of Indonesia?
Offer a very short reply. -3.08. In the year 2009, what is the difference between the Exports(as % of merchandise exports) of High income and Exports(as % of merchandise exports) of Vietnam?
Give a very brief answer. -0.95. In the year 2009, what is the difference between the Exports(as % of merchandise exports) of Indonesia and Exports(as % of merchandise exports) of Vietnam?
Your response must be concise. 2.13. In the year 2010, what is the difference between the Exports(as % of merchandise exports) in Europe(all income levels) and Exports(as % of merchandise exports) in High income?
Keep it short and to the point. -0.25. In the year 2010, what is the difference between the Exports(as % of merchandise exports) of Europe(all income levels) and Exports(as % of merchandise exports) of Indonesia?
Provide a short and direct response. -5.17. In the year 2010, what is the difference between the Exports(as % of merchandise exports) of Europe(all income levels) and Exports(as % of merchandise exports) of Vietnam?
Your response must be concise. -2.05. In the year 2010, what is the difference between the Exports(as % of merchandise exports) of High income and Exports(as % of merchandise exports) of Indonesia?
Offer a terse response. -4.92. In the year 2010, what is the difference between the Exports(as % of merchandise exports) of High income and Exports(as % of merchandise exports) of Vietnam?
Provide a short and direct response. -1.8. In the year 2010, what is the difference between the Exports(as % of merchandise exports) of Indonesia and Exports(as % of merchandise exports) of Vietnam?
Your answer should be very brief. 3.12. In the year 2011, what is the difference between the Exports(as % of merchandise exports) in Europe(all income levels) and Exports(as % of merchandise exports) in High income?
Your answer should be compact. -0.29. In the year 2011, what is the difference between the Exports(as % of merchandise exports) in Europe(all income levels) and Exports(as % of merchandise exports) in Indonesia?
Keep it short and to the point. -6.09. In the year 2011, what is the difference between the Exports(as % of merchandise exports) of Europe(all income levels) and Exports(as % of merchandise exports) of Vietnam?
Keep it short and to the point. -2.21. In the year 2011, what is the difference between the Exports(as % of merchandise exports) in High income and Exports(as % of merchandise exports) in Indonesia?
Offer a terse response. -5.79. In the year 2011, what is the difference between the Exports(as % of merchandise exports) in High income and Exports(as % of merchandise exports) in Vietnam?
Provide a short and direct response. -1.92. In the year 2011, what is the difference between the Exports(as % of merchandise exports) of Indonesia and Exports(as % of merchandise exports) of Vietnam?
Provide a succinct answer. 3.88. What is the ratio of the Exports(as % of merchandise exports) in Europe(all income levels) in 2005 to that in 2006?
Keep it short and to the point. 1.02. What is the ratio of the Exports(as % of merchandise exports) of High income in 2005 to that in 2006?
Your response must be concise. 1.03. What is the ratio of the Exports(as % of merchandise exports) in Indonesia in 2005 to that in 2006?
Make the answer very short. 0.79. What is the ratio of the Exports(as % of merchandise exports) of Vietnam in 2005 to that in 2006?
Make the answer very short. 0.75. What is the ratio of the Exports(as % of merchandise exports) in Europe(all income levels) in 2005 to that in 2007?
Your answer should be very brief. 1.02. What is the ratio of the Exports(as % of merchandise exports) in High income in 2005 to that in 2007?
Ensure brevity in your answer.  1.03. What is the ratio of the Exports(as % of merchandise exports) of Indonesia in 2005 to that in 2007?
Your answer should be compact. 0.81. What is the ratio of the Exports(as % of merchandise exports) of Vietnam in 2005 to that in 2007?
Give a very brief answer. 0.81. What is the ratio of the Exports(as % of merchandise exports) in Europe(all income levels) in 2005 to that in 2008?
Offer a terse response. 1.13. What is the ratio of the Exports(as % of merchandise exports) in Indonesia in 2005 to that in 2008?
Your answer should be compact. 0.79. What is the ratio of the Exports(as % of merchandise exports) of Vietnam in 2005 to that in 2008?
Keep it short and to the point. 0.96. What is the ratio of the Exports(as % of merchandise exports) in Europe(all income levels) in 2005 to that in 2009?
Provide a short and direct response. 1.08. What is the ratio of the Exports(as % of merchandise exports) of High income in 2005 to that in 2009?
Provide a short and direct response. 1.06. What is the ratio of the Exports(as % of merchandise exports) of Indonesia in 2005 to that in 2009?
Keep it short and to the point. 1.12. What is the ratio of the Exports(as % of merchandise exports) of Vietnam in 2005 to that in 2009?
Give a very brief answer. 1.17. What is the ratio of the Exports(as % of merchandise exports) of Europe(all income levels) in 2005 to that in 2010?
Offer a very short reply. 1.01. What is the ratio of the Exports(as % of merchandise exports) of High income in 2005 to that in 2010?
Provide a succinct answer. 0.95. What is the ratio of the Exports(as % of merchandise exports) in Indonesia in 2005 to that in 2010?
Make the answer very short. 0.77. What is the ratio of the Exports(as % of merchandise exports) in Vietnam in 2005 to that in 2010?
Offer a terse response. 0.82. What is the ratio of the Exports(as % of merchandise exports) of Europe(all income levels) in 2005 to that in 2011?
Make the answer very short. 0.97. What is the ratio of the Exports(as % of merchandise exports) of High income in 2005 to that in 2011?
Make the answer very short. 0.89. What is the ratio of the Exports(as % of merchandise exports) of Indonesia in 2005 to that in 2011?
Keep it short and to the point. 0.67. What is the ratio of the Exports(as % of merchandise exports) in Vietnam in 2005 to that in 2011?
Provide a succinct answer. 0.77. What is the ratio of the Exports(as % of merchandise exports) in Indonesia in 2006 to that in 2007?
Offer a very short reply. 1.03. What is the ratio of the Exports(as % of merchandise exports) in Vietnam in 2006 to that in 2007?
Your answer should be very brief. 1.08. What is the ratio of the Exports(as % of merchandise exports) in Europe(all income levels) in 2006 to that in 2008?
Offer a very short reply. 1.11. What is the ratio of the Exports(as % of merchandise exports) of High income in 2006 to that in 2008?
Provide a short and direct response. 1.07. What is the ratio of the Exports(as % of merchandise exports) of Vietnam in 2006 to that in 2008?
Offer a terse response. 1.29. What is the ratio of the Exports(as % of merchandise exports) of Europe(all income levels) in 2006 to that in 2009?
Give a very brief answer. 1.05. What is the ratio of the Exports(as % of merchandise exports) in High income in 2006 to that in 2009?
Offer a terse response. 1.04. What is the ratio of the Exports(as % of merchandise exports) of Indonesia in 2006 to that in 2009?
Provide a short and direct response. 1.42. What is the ratio of the Exports(as % of merchandise exports) of Vietnam in 2006 to that in 2009?
Provide a succinct answer. 1.56. What is the ratio of the Exports(as % of merchandise exports) of Europe(all income levels) in 2006 to that in 2010?
Your response must be concise. 0.99. What is the ratio of the Exports(as % of merchandise exports) of High income in 2006 to that in 2010?
Provide a short and direct response. 0.93. What is the ratio of the Exports(as % of merchandise exports) of Indonesia in 2006 to that in 2010?
Keep it short and to the point. 0.98. What is the ratio of the Exports(as % of merchandise exports) of Vietnam in 2006 to that in 2010?
Offer a very short reply. 1.1. What is the ratio of the Exports(as % of merchandise exports) of Europe(all income levels) in 2006 to that in 2011?
Provide a succinct answer. 0.94. What is the ratio of the Exports(as % of merchandise exports) of High income in 2006 to that in 2011?
Provide a short and direct response. 0.87. What is the ratio of the Exports(as % of merchandise exports) of Indonesia in 2006 to that in 2011?
Keep it short and to the point. 0.85. What is the ratio of the Exports(as % of merchandise exports) of Vietnam in 2006 to that in 2011?
Give a very brief answer. 1.03. What is the ratio of the Exports(as % of merchandise exports) in Europe(all income levels) in 2007 to that in 2008?
Keep it short and to the point. 1.11. What is the ratio of the Exports(as % of merchandise exports) of High income in 2007 to that in 2008?
Offer a terse response. 1.07. What is the ratio of the Exports(as % of merchandise exports) in Indonesia in 2007 to that in 2008?
Your answer should be compact. 0.97. What is the ratio of the Exports(as % of merchandise exports) of Vietnam in 2007 to that in 2008?
Offer a very short reply. 1.19. What is the ratio of the Exports(as % of merchandise exports) in Europe(all income levels) in 2007 to that in 2009?
Give a very brief answer. 1.05. What is the ratio of the Exports(as % of merchandise exports) of High income in 2007 to that in 2009?
Keep it short and to the point. 1.03. What is the ratio of the Exports(as % of merchandise exports) of Indonesia in 2007 to that in 2009?
Give a very brief answer. 1.38. What is the ratio of the Exports(as % of merchandise exports) in Vietnam in 2007 to that in 2009?
Provide a succinct answer. 1.45. What is the ratio of the Exports(as % of merchandise exports) in High income in 2007 to that in 2010?
Ensure brevity in your answer.  0.92. What is the ratio of the Exports(as % of merchandise exports) of Indonesia in 2007 to that in 2010?
Your answer should be very brief. 0.96. What is the ratio of the Exports(as % of merchandise exports) of Vietnam in 2007 to that in 2010?
Offer a terse response. 1.02. What is the ratio of the Exports(as % of merchandise exports) in Europe(all income levels) in 2007 to that in 2011?
Your response must be concise. 0.95. What is the ratio of the Exports(as % of merchandise exports) of High income in 2007 to that in 2011?
Offer a terse response. 0.86. What is the ratio of the Exports(as % of merchandise exports) in Indonesia in 2007 to that in 2011?
Ensure brevity in your answer.  0.83. What is the ratio of the Exports(as % of merchandise exports) of Vietnam in 2007 to that in 2011?
Offer a terse response. 0.95. What is the ratio of the Exports(as % of merchandise exports) in Europe(all income levels) in 2008 to that in 2009?
Provide a succinct answer. 0.95. What is the ratio of the Exports(as % of merchandise exports) of High income in 2008 to that in 2009?
Offer a very short reply. 0.97. What is the ratio of the Exports(as % of merchandise exports) in Indonesia in 2008 to that in 2009?
Provide a succinct answer. 1.42. What is the ratio of the Exports(as % of merchandise exports) in Vietnam in 2008 to that in 2009?
Your answer should be compact. 1.21. What is the ratio of the Exports(as % of merchandise exports) of Europe(all income levels) in 2008 to that in 2010?
Your response must be concise. 0.89. What is the ratio of the Exports(as % of merchandise exports) in High income in 2008 to that in 2010?
Ensure brevity in your answer.  0.86. What is the ratio of the Exports(as % of merchandise exports) of Indonesia in 2008 to that in 2010?
Your answer should be very brief. 0.98. What is the ratio of the Exports(as % of merchandise exports) of Vietnam in 2008 to that in 2010?
Offer a terse response. 0.85. What is the ratio of the Exports(as % of merchandise exports) of Europe(all income levels) in 2008 to that in 2011?
Ensure brevity in your answer.  0.85. What is the ratio of the Exports(as % of merchandise exports) in High income in 2008 to that in 2011?
Make the answer very short. 0.81. What is the ratio of the Exports(as % of merchandise exports) in Indonesia in 2008 to that in 2011?
Your response must be concise. 0.86. What is the ratio of the Exports(as % of merchandise exports) in Vietnam in 2008 to that in 2011?
Offer a terse response. 0.8. What is the ratio of the Exports(as % of merchandise exports) in Europe(all income levels) in 2009 to that in 2010?
Offer a very short reply. 0.94. What is the ratio of the Exports(as % of merchandise exports) in High income in 2009 to that in 2010?
Keep it short and to the point. 0.89. What is the ratio of the Exports(as % of merchandise exports) of Indonesia in 2009 to that in 2010?
Ensure brevity in your answer.  0.69. What is the ratio of the Exports(as % of merchandise exports) in Vietnam in 2009 to that in 2010?
Give a very brief answer. 0.7. What is the ratio of the Exports(as % of merchandise exports) of Europe(all income levels) in 2009 to that in 2011?
Provide a short and direct response. 0.9. What is the ratio of the Exports(as % of merchandise exports) of High income in 2009 to that in 2011?
Give a very brief answer. 0.84. What is the ratio of the Exports(as % of merchandise exports) in Indonesia in 2009 to that in 2011?
Offer a very short reply. 0.6. What is the ratio of the Exports(as % of merchandise exports) in Vietnam in 2009 to that in 2011?
Provide a short and direct response. 0.66. What is the ratio of the Exports(as % of merchandise exports) of Europe(all income levels) in 2010 to that in 2011?
Ensure brevity in your answer.  0.96. What is the ratio of the Exports(as % of merchandise exports) in High income in 2010 to that in 2011?
Your answer should be compact. 0.94. What is the ratio of the Exports(as % of merchandise exports) in Indonesia in 2010 to that in 2011?
Your answer should be very brief. 0.87. What is the ratio of the Exports(as % of merchandise exports) of Vietnam in 2010 to that in 2011?
Offer a very short reply. 0.94. What is the difference between the highest and the second highest Exports(as % of merchandise exports) of Europe(all income levels)?
Your answer should be very brief. 0.05. What is the difference between the highest and the second highest Exports(as % of merchandise exports) of High income?
Offer a terse response. 0.11. What is the difference between the highest and the second highest Exports(as % of merchandise exports) in Indonesia?
Your response must be concise. 0.98. What is the difference between the highest and the second highest Exports(as % of merchandise exports) of Vietnam?
Provide a succinct answer. 0.11. What is the difference between the highest and the lowest Exports(as % of merchandise exports) of Europe(all income levels)?
Make the answer very short. 0.21. What is the difference between the highest and the lowest Exports(as % of merchandise exports) of High income?
Your answer should be compact. 0.33. What is the difference between the highest and the lowest Exports(as % of merchandise exports) of Indonesia?
Your answer should be compact. 2.99. What is the difference between the highest and the lowest Exports(as % of merchandise exports) of Vietnam?
Make the answer very short. 1.35. 